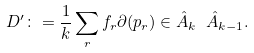Convert formula to latex. <formula><loc_0><loc_0><loc_500><loc_500>D ^ { \prime } \colon = \frac { 1 } { k } \sum _ { r } f _ { r } \partial ( p _ { r } ) \in \hat { A } _ { k } \ \hat { A } _ { k - 1 } .</formula> 